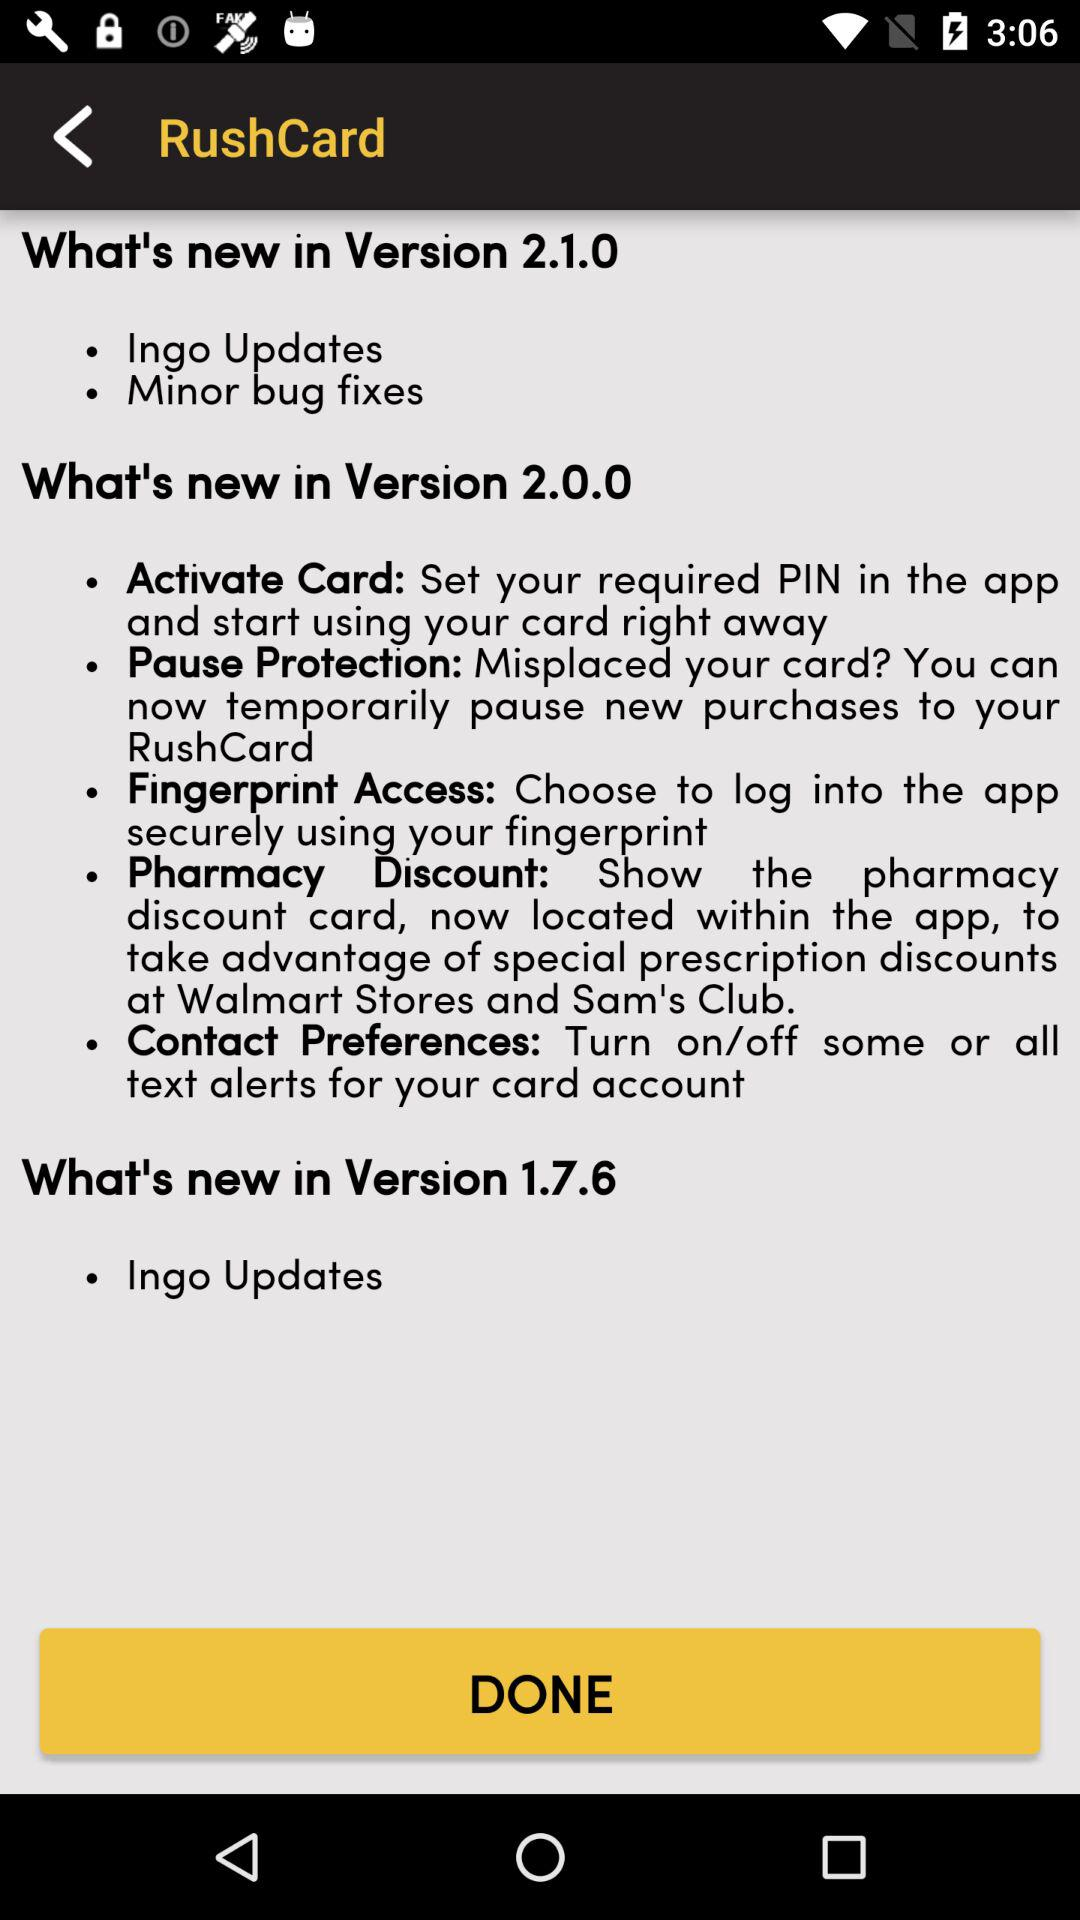In what version do we get the update with minor bug fixes? In version 2.1.0, you get the update with minor bug fixes. 